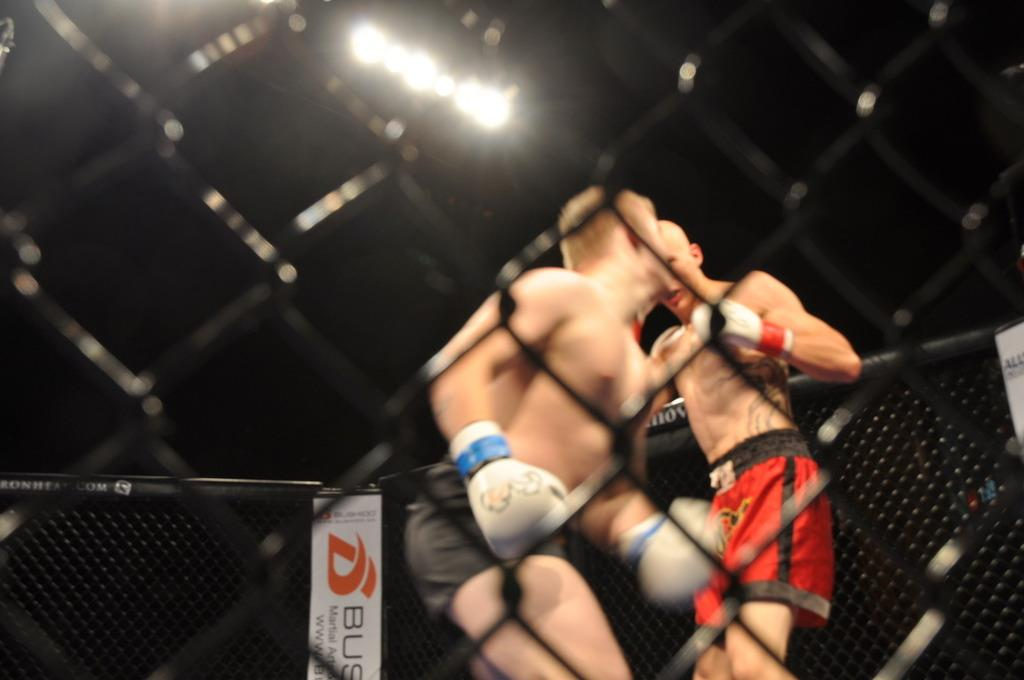What is the main subject of the image? The main subject of the image is a boxing ring. What are the two persons in the image doing? They are fighting in the boxing ring. Can you describe the lighting in the image? There is a light at the top of the image. How would you describe the background of the image? The background of the image is dark. What type of cabbage is being used as a punching bag in the image? There is no cabbage present in the image, and it is not being used as a punching bag. How does the disgusting smell in the image affect the fighters? There is no mention of a disgusting smell in the image, so it cannot affect the fighters. 